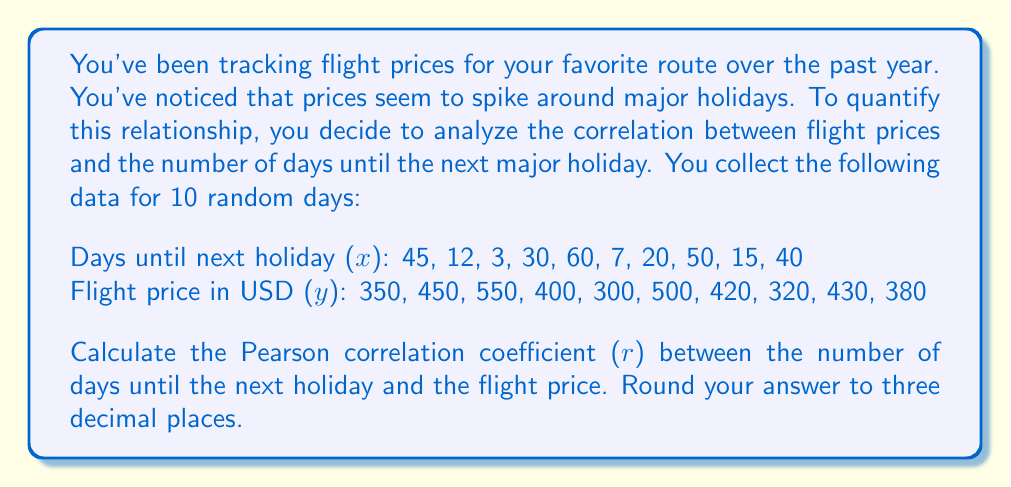Provide a solution to this math problem. To calculate the Pearson correlation coefficient, we'll use the formula:

$$ r = \frac{\sum_{i=1}^{n} (x_i - \bar{x})(y_i - \bar{y})}{\sqrt{\sum_{i=1}^{n} (x_i - \bar{x})^2 \sum_{i=1}^{n} (y_i - \bar{y})^2}} $$

Where:
$x_i$ = days until next holiday
$y_i$ = flight price
$\bar{x}$ = mean of x
$\bar{y}$ = mean of y
$n$ = number of data points (10)

Step 1: Calculate means
$\bar{x} = \frac{45 + 12 + 3 + 30 + 60 + 7 + 20 + 50 + 15 + 40}{10} = 28.2$
$\bar{y} = \frac{350 + 450 + 550 + 400 + 300 + 500 + 420 + 320 + 430 + 380}{10} = 410$

Step 2: Calculate $(x_i - \bar{x})$, $(y_i - \bar{y})$, $(x_i - \bar{x})^2$, $(y_i - \bar{y})^2$, and $(x_i - \bar{x})(y_i - \bar{y})$

Step 3: Sum the results
$\sum (x_i - \bar{x})(y_i - \bar{y}) = -13,190$
$\sum (x_i - \bar{x})^2 = 4,183.6$
$\sum (y_i - \bar{y})^2 = 85,000$

Step 4: Apply the formula
$$ r = \frac{-13,190}{\sqrt{4,183.6 \times 85,000}} = -0.7003 $$

Step 5: Round to three decimal places
$r = -0.700$
Answer: -0.700 